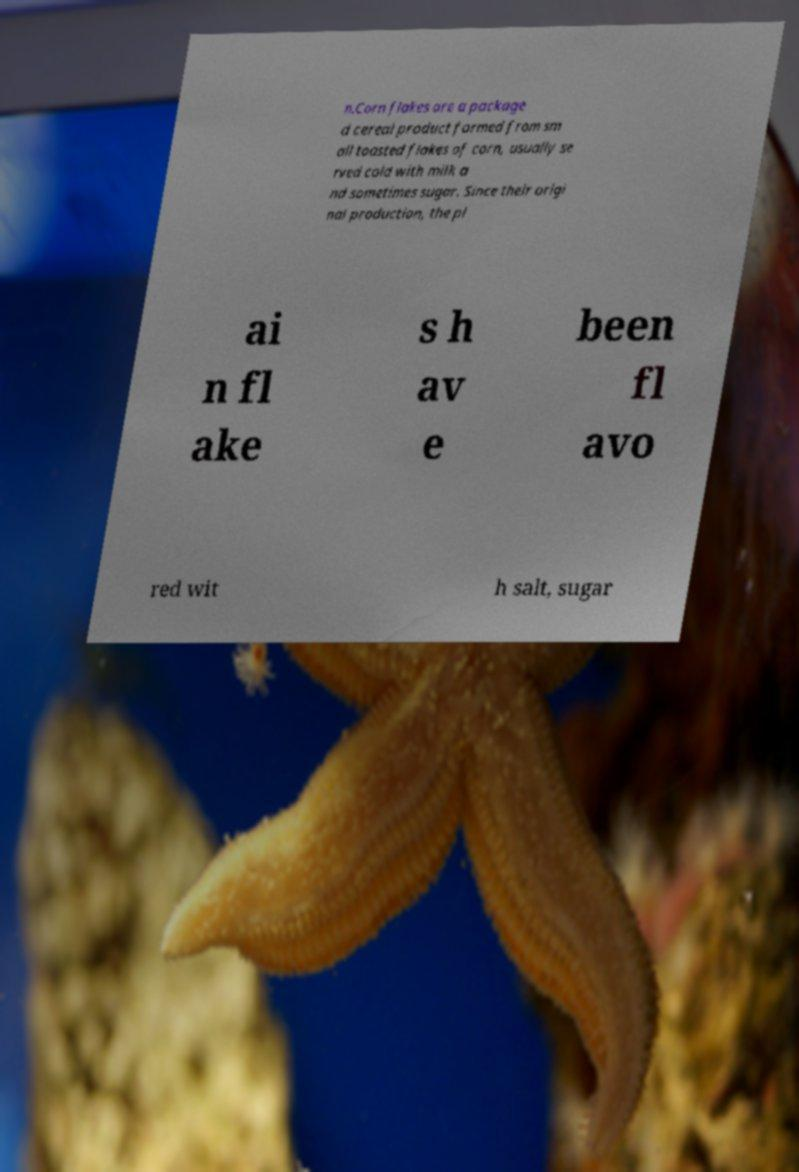Please identify and transcribe the text found in this image. n.Corn flakes are a package d cereal product formed from sm all toasted flakes of corn, usually se rved cold with milk a nd sometimes sugar. Since their origi nal production, the pl ai n fl ake s h av e been fl avo red wit h salt, sugar 